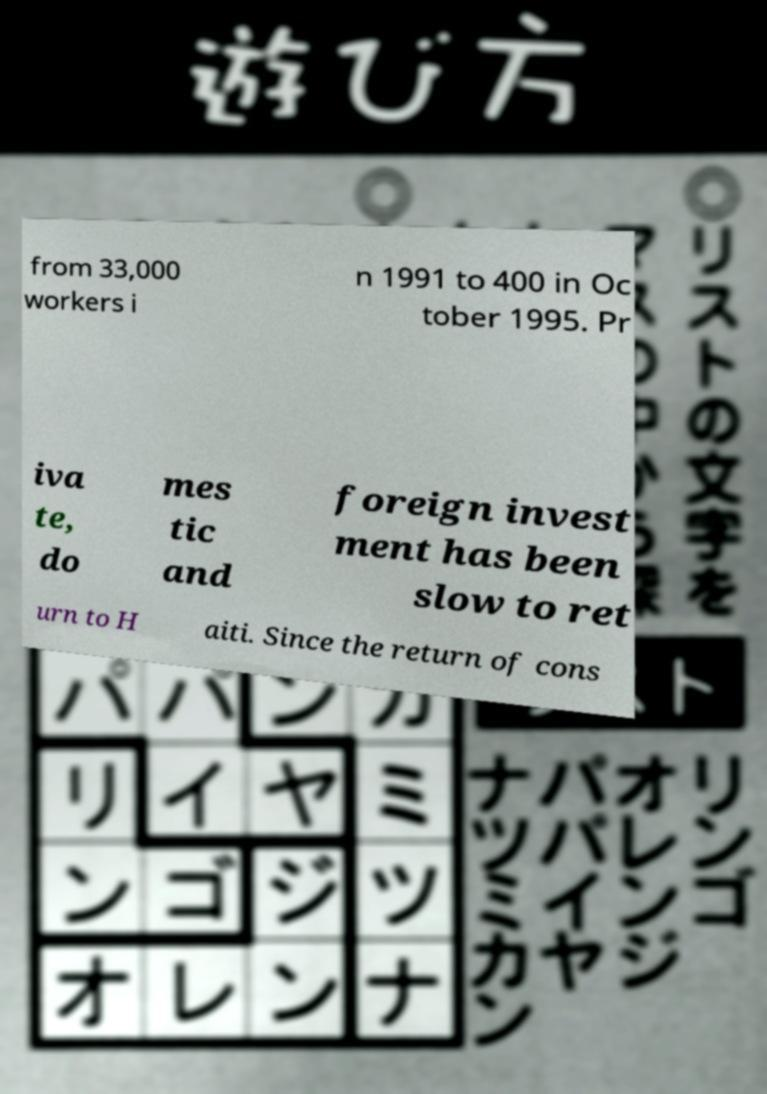For documentation purposes, I need the text within this image transcribed. Could you provide that? from 33,000 workers i n 1991 to 400 in Oc tober 1995. Pr iva te, do mes tic and foreign invest ment has been slow to ret urn to H aiti. Since the return of cons 